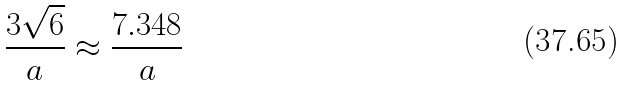<formula> <loc_0><loc_0><loc_500><loc_500>\frac { 3 \sqrt { 6 } } { a } \approx \frac { 7 . 3 4 8 } { a }</formula> 